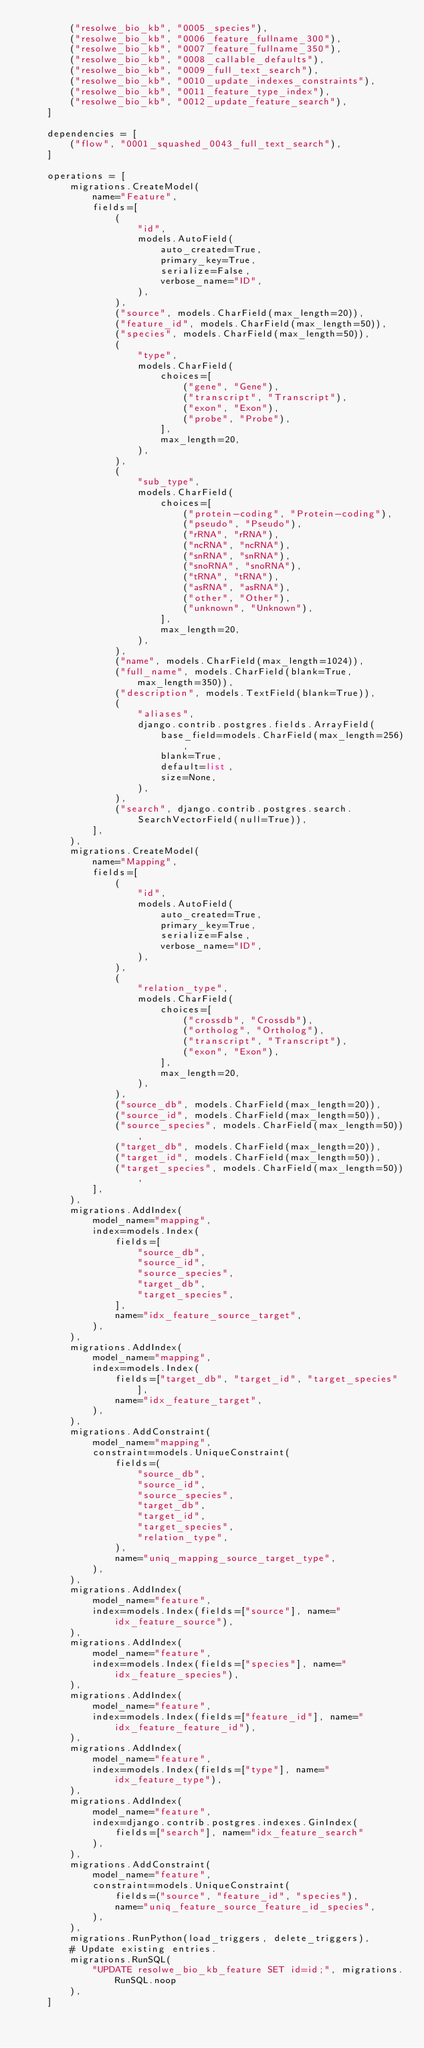<code> <loc_0><loc_0><loc_500><loc_500><_Python_>        ("resolwe_bio_kb", "0005_species"),
        ("resolwe_bio_kb", "0006_feature_fullname_300"),
        ("resolwe_bio_kb", "0007_feature_fullname_350"),
        ("resolwe_bio_kb", "0008_callable_defaults"),
        ("resolwe_bio_kb", "0009_full_text_search"),
        ("resolwe_bio_kb", "0010_update_indexes_constraints"),
        ("resolwe_bio_kb", "0011_feature_type_index"),
        ("resolwe_bio_kb", "0012_update_feature_search"),
    ]

    dependencies = [
        ("flow", "0001_squashed_0043_full_text_search"),
    ]

    operations = [
        migrations.CreateModel(
            name="Feature",
            fields=[
                (
                    "id",
                    models.AutoField(
                        auto_created=True,
                        primary_key=True,
                        serialize=False,
                        verbose_name="ID",
                    ),
                ),
                ("source", models.CharField(max_length=20)),
                ("feature_id", models.CharField(max_length=50)),
                ("species", models.CharField(max_length=50)),
                (
                    "type",
                    models.CharField(
                        choices=[
                            ("gene", "Gene"),
                            ("transcript", "Transcript"),
                            ("exon", "Exon"),
                            ("probe", "Probe"),
                        ],
                        max_length=20,
                    ),
                ),
                (
                    "sub_type",
                    models.CharField(
                        choices=[
                            ("protein-coding", "Protein-coding"),
                            ("pseudo", "Pseudo"),
                            ("rRNA", "rRNA"),
                            ("ncRNA", "ncRNA"),
                            ("snRNA", "snRNA"),
                            ("snoRNA", "snoRNA"),
                            ("tRNA", "tRNA"),
                            ("asRNA", "asRNA"),
                            ("other", "Other"),
                            ("unknown", "Unknown"),
                        ],
                        max_length=20,
                    ),
                ),
                ("name", models.CharField(max_length=1024)),
                ("full_name", models.CharField(blank=True, max_length=350)),
                ("description", models.TextField(blank=True)),
                (
                    "aliases",
                    django.contrib.postgres.fields.ArrayField(
                        base_field=models.CharField(max_length=256),
                        blank=True,
                        default=list,
                        size=None,
                    ),
                ),
                ("search", django.contrib.postgres.search.SearchVectorField(null=True)),
            ],
        ),
        migrations.CreateModel(
            name="Mapping",
            fields=[
                (
                    "id",
                    models.AutoField(
                        auto_created=True,
                        primary_key=True,
                        serialize=False,
                        verbose_name="ID",
                    ),
                ),
                (
                    "relation_type",
                    models.CharField(
                        choices=[
                            ("crossdb", "Crossdb"),
                            ("ortholog", "Ortholog"),
                            ("transcript", "Transcript"),
                            ("exon", "Exon"),
                        ],
                        max_length=20,
                    ),
                ),
                ("source_db", models.CharField(max_length=20)),
                ("source_id", models.CharField(max_length=50)),
                ("source_species", models.CharField(max_length=50)),
                ("target_db", models.CharField(max_length=20)),
                ("target_id", models.CharField(max_length=50)),
                ("target_species", models.CharField(max_length=50)),
            ],
        ),
        migrations.AddIndex(
            model_name="mapping",
            index=models.Index(
                fields=[
                    "source_db",
                    "source_id",
                    "source_species",
                    "target_db",
                    "target_species",
                ],
                name="idx_feature_source_target",
            ),
        ),
        migrations.AddIndex(
            model_name="mapping",
            index=models.Index(
                fields=["target_db", "target_id", "target_species"],
                name="idx_feature_target",
            ),
        ),
        migrations.AddConstraint(
            model_name="mapping",
            constraint=models.UniqueConstraint(
                fields=(
                    "source_db",
                    "source_id",
                    "source_species",
                    "target_db",
                    "target_id",
                    "target_species",
                    "relation_type",
                ),
                name="uniq_mapping_source_target_type",
            ),
        ),
        migrations.AddIndex(
            model_name="feature",
            index=models.Index(fields=["source"], name="idx_feature_source"),
        ),
        migrations.AddIndex(
            model_name="feature",
            index=models.Index(fields=["species"], name="idx_feature_species"),
        ),
        migrations.AddIndex(
            model_name="feature",
            index=models.Index(fields=["feature_id"], name="idx_feature_feature_id"),
        ),
        migrations.AddIndex(
            model_name="feature",
            index=models.Index(fields=["type"], name="idx_feature_type"),
        ),
        migrations.AddIndex(
            model_name="feature",
            index=django.contrib.postgres.indexes.GinIndex(
                fields=["search"], name="idx_feature_search"
            ),
        ),
        migrations.AddConstraint(
            model_name="feature",
            constraint=models.UniqueConstraint(
                fields=("source", "feature_id", "species"),
                name="uniq_feature_source_feature_id_species",
            ),
        ),
        migrations.RunPython(load_triggers, delete_triggers),
        # Update existing entries.
        migrations.RunSQL(
            "UPDATE resolwe_bio_kb_feature SET id=id;", migrations.RunSQL.noop
        ),
    ]
</code> 